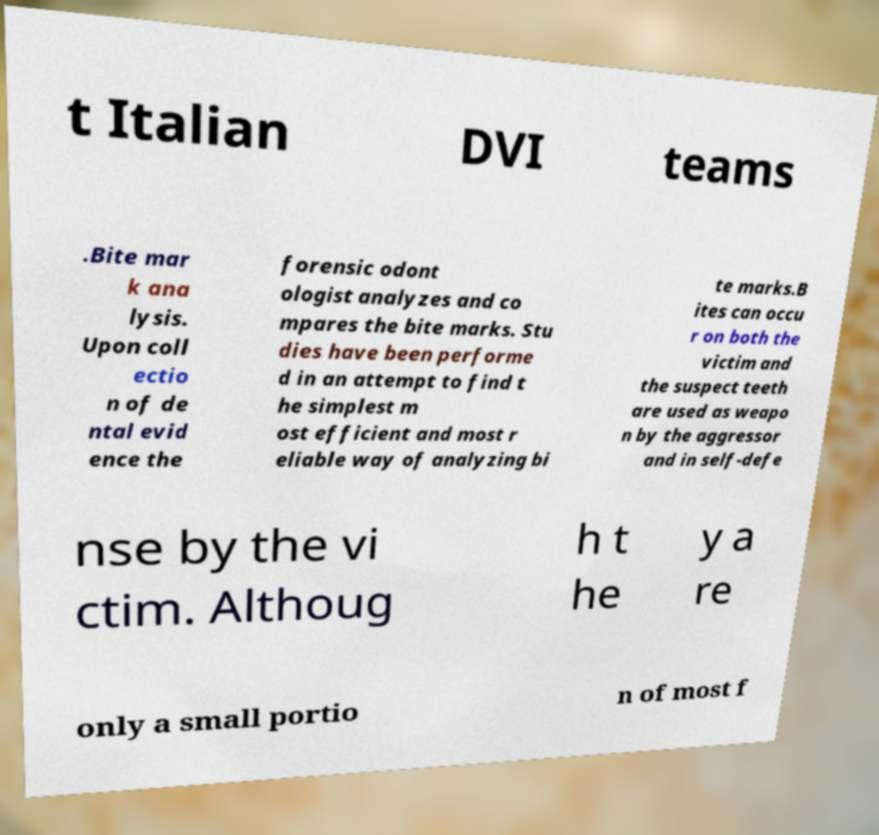Could you extract and type out the text from this image? t Italian DVI teams .Bite mar k ana lysis. Upon coll ectio n of de ntal evid ence the forensic odont ologist analyzes and co mpares the bite marks. Stu dies have been performe d in an attempt to find t he simplest m ost efficient and most r eliable way of analyzing bi te marks.B ites can occu r on both the victim and the suspect teeth are used as weapo n by the aggressor and in self-defe nse by the vi ctim. Althoug h t he y a re only a small portio n of most f 